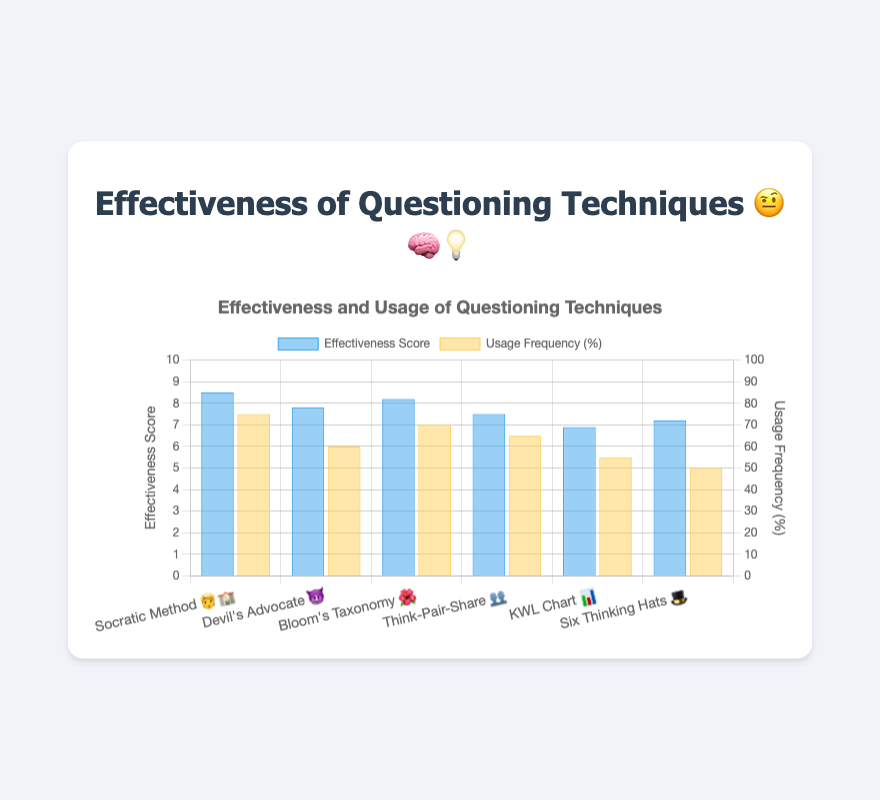What is the effectiveness score of the "Socratic Method 🧑‍🏫"? The effectiveness score of the "Socratic Method 🧑‍🏫" is directly shown in the chart.
Answer: 8.5 How frequently is "Bloom's Taxonomy 🌺" used compared to "Think-Pair-Share 👥"? To compare usage frequency, look at the bars representing usage frequency for both techniques. "Bloom's Taxonomy 🌺" has a frequency of 70%, while "Think-Pair-Share 👥" has 65%.
Answer: "Bloom's Taxonomy 🌺" is used 5% more frequently than "Think-Pair-Share 👥" Which technique has the lowest effectiveness score? Look at the effectiveness scores for all techniques and identify the lowest value. "KWL Chart 📊" has the lowest effectiveness score of 6.9.
Answer: "KWL Chart 📊" What is the average effectiveness score of all techniques? Sum the effectiveness scores of all techniques (8.5 + 7.8 + 8.2 + 7.5 + 6.9 + 7.2 = 46.1) and divide by the number of techniques (6).
Answer: 7.68 Which technique has the highest usage frequency? Look at the usage frequency for all techniques and identify the highest value. The "Socratic Method 🧑‍🏫" has the highest usage frequency of 75%.
Answer: "Socratic Method 🧑‍🏫" How does the effectiveness of "Six Thinking Hats 🎩" compare to "Devil's Advocate 😈"? Compare the effectiveness scores of the two techniques. "Six Thinking Hats 🎩" has a score of 7.2, while "Devil's Advocate 😈" has 7.8.
Answer: "Devil's Advocate 😈" is more effective What is the sum of the usage frequencies for "Think-Pair-Share 👥" and "KWL Chart 📊"? Add the usage frequencies for "Think-Pair-Share 👥" (65%) and "KWL Chart 📊" (55%).
Answer: 120% How much more effective is "Bloom's Taxonomy 🌺" than "Six Thinking Hats 🎩"? Subtract the effectiveness score of "Six Thinking Hats 🎩" (7.2) from that of "Bloom's Taxonomy 🌺" (8.2).
Answer: 1.0 What is the ratio of effectiveness to usage frequency for "Devil's Advocate 😈"? Divide the effectiveness score of "Devil's Advocate 😈" (7.8) by its usage frequency (60) and multiply by 100%.
Answer: 13% Which technique has the smallest gap between effectiveness score and usage frequency? Calculate the gaps for each technique and identify the smallest one. "Think-Pair-Share 👥" has a gap of
Answer: 7.5% 